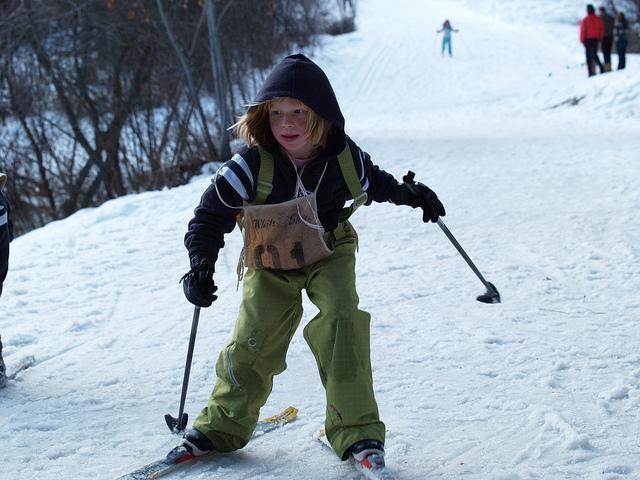How many elephant feet are lifted?
Give a very brief answer. 0. 